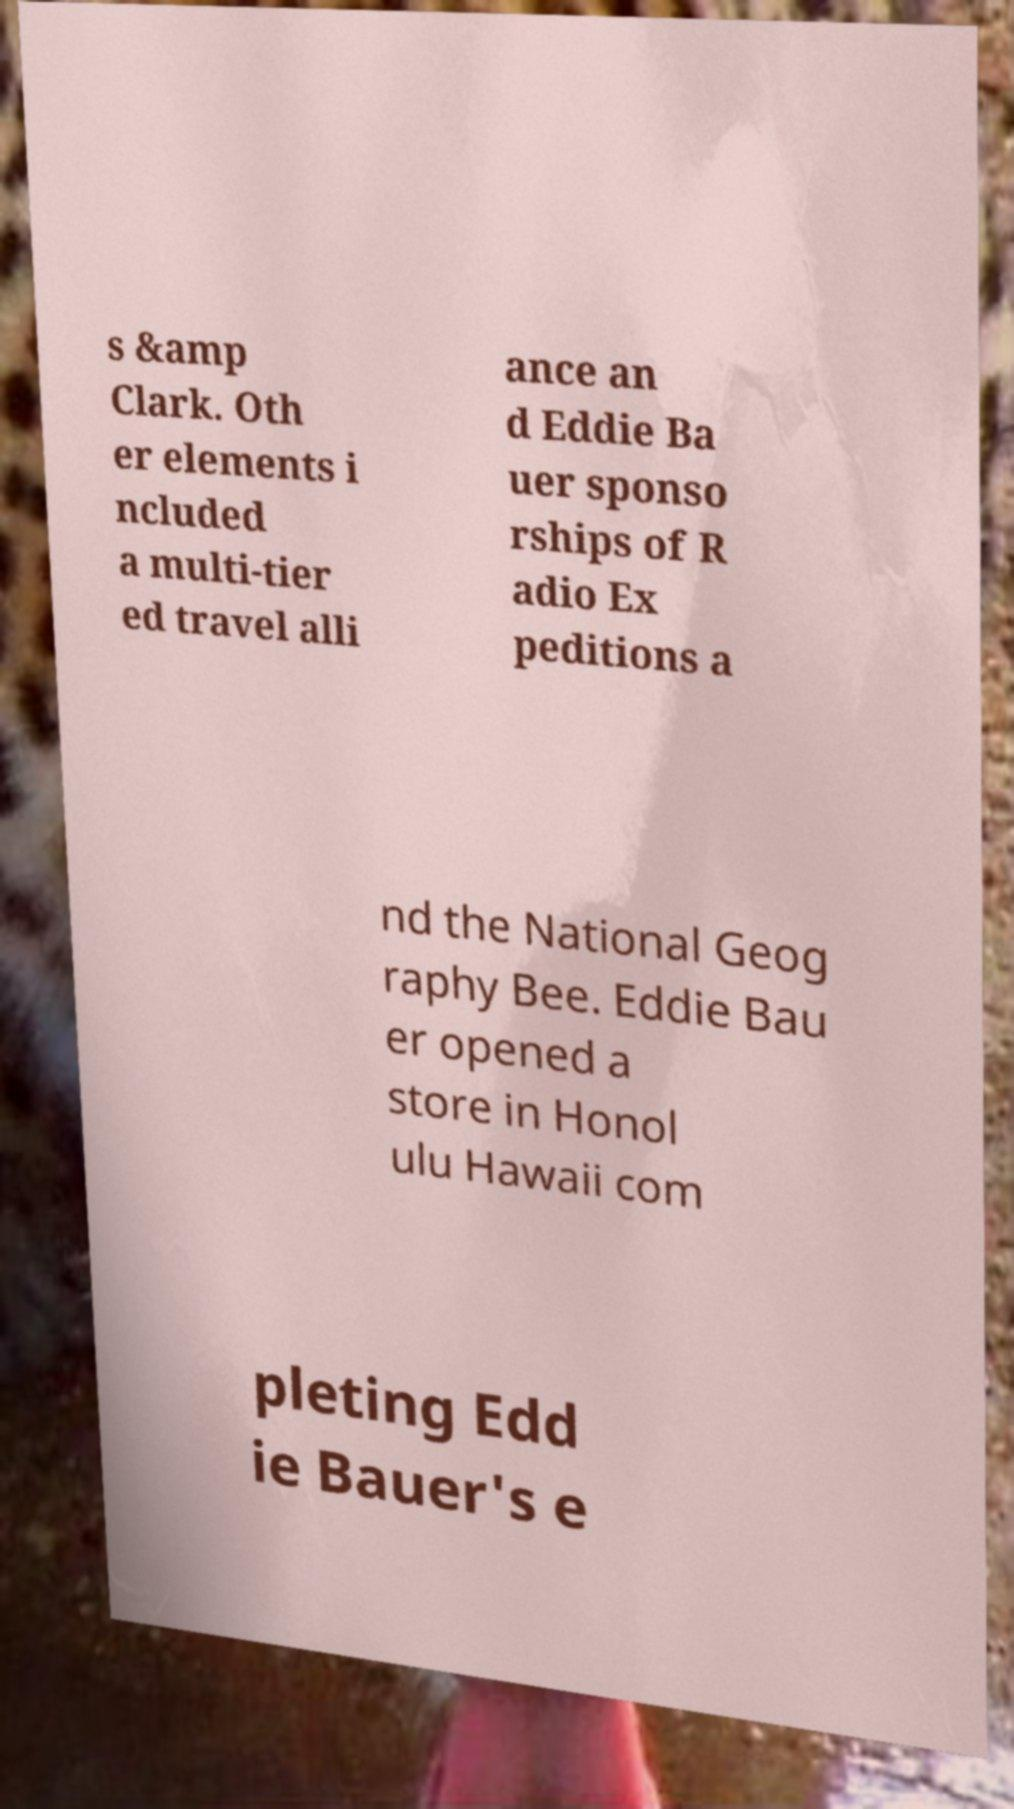Could you assist in decoding the text presented in this image and type it out clearly? s &amp Clark. Oth er elements i ncluded a multi-tier ed travel alli ance an d Eddie Ba uer sponso rships of R adio Ex peditions a nd the National Geog raphy Bee. Eddie Bau er opened a store in Honol ulu Hawaii com pleting Edd ie Bauer's e 